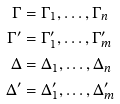<formula> <loc_0><loc_0><loc_500><loc_500>\Gamma & = \Gamma _ { 1 } , \dots , \Gamma _ { n } \\ \Gamma ^ { \prime } & = \Gamma _ { 1 } ^ { \prime } , \dots , \Gamma _ { m } ^ { \prime } \\ \Delta & = \Delta _ { 1 } , \dots , \Delta _ { n } \\ \Delta ^ { \prime } & = \Delta _ { 1 } ^ { \prime } , \dots , \Delta _ { m } ^ { \prime }</formula> 